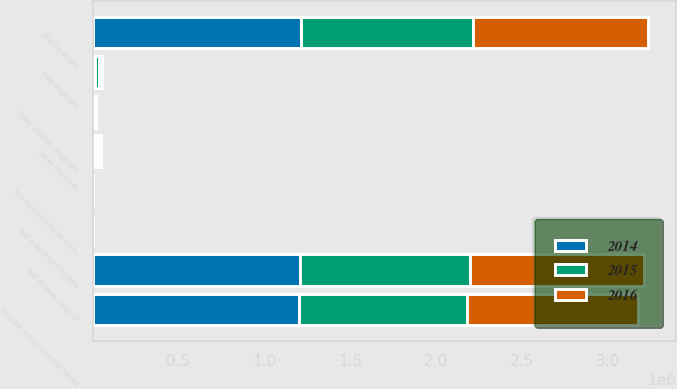<chart> <loc_0><loc_0><loc_500><loc_500><stacked_bar_chart><ecel><fcel>Net investment income<fcel>Net realized capital gains<fcel>Other income (expense)<fcel>Net income (loss) of<fcel>Total revenues<fcel>Other expenses<fcel>Total expenses<fcel>INCOME (LOSS) BEFORE TAXES<nl><fcel>2016<fcel>879<fcel>144<fcel>5022<fcel>1.01232e+06<fcel>1.01836e+06<fcel>17716<fcel>22016<fcel>996344<nl><fcel>2015<fcel>3895<fcel>3057<fcel>7809<fcel>989462<fcel>998109<fcel>15940<fcel>20240<fcel>977869<nl><fcel>2014<fcel>824<fcel>15<fcel>5568<fcel>1.20819e+06<fcel>1.2146e+06<fcel>15443<fcel>15443<fcel>1.19916e+06<nl></chart> 